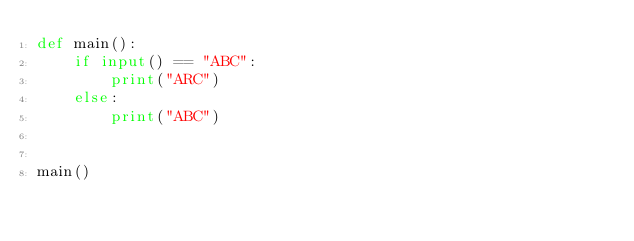Convert code to text. <code><loc_0><loc_0><loc_500><loc_500><_Python_>def main():
    if input() == "ABC":
        print("ARC")
    else:
        print("ABC")


main()
</code> 